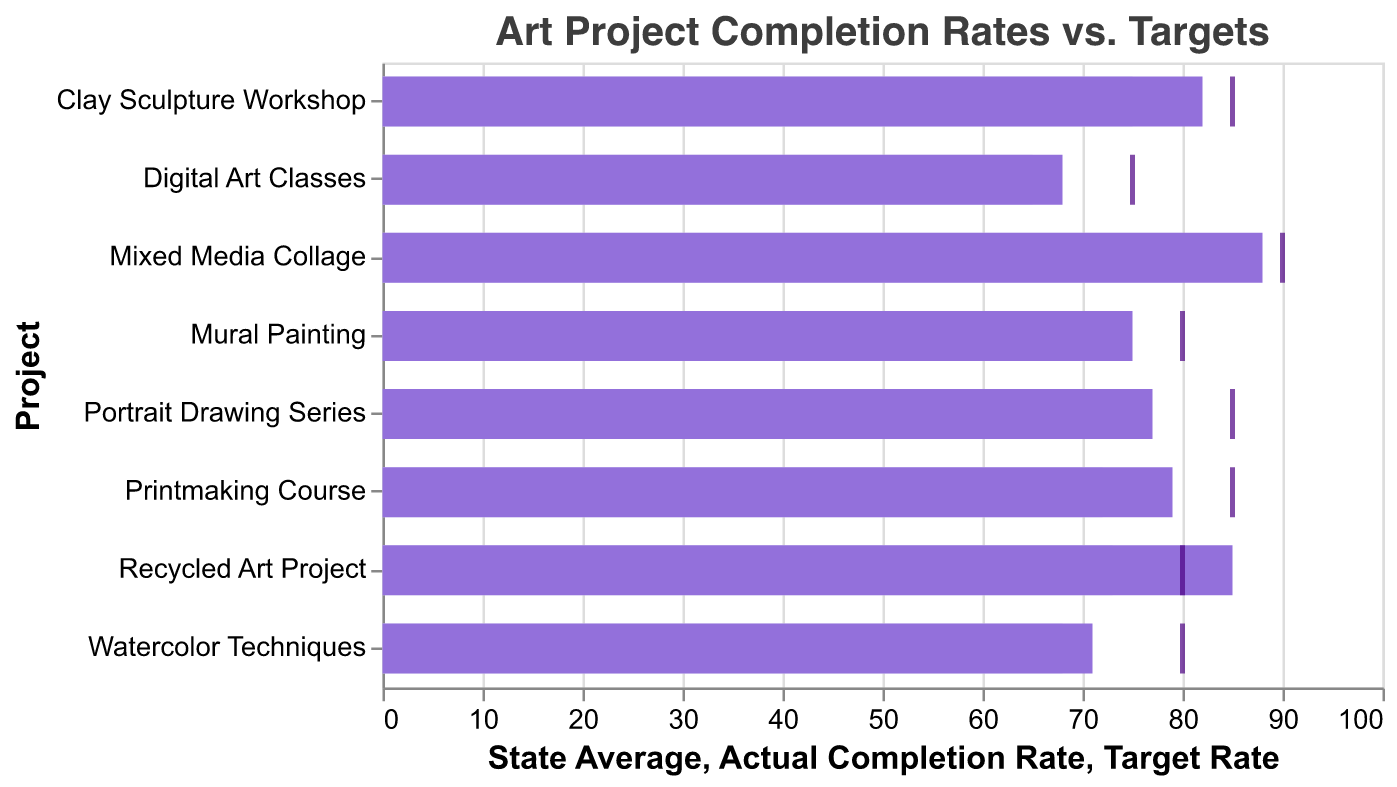What is the title of the figure? The title of the figure is displayed at the top and is usually in larger font size or bold for emphasis.
Answer: Art Project Completion Rates vs. Targets Which art project has the lowest actual completion rate? The lowest actual completion rate is represented by the shortest purple bar.
Answer: Digital Art Classes How many projects have an actual completion rate that meets or exceeds the target rate? Compare the length of the purple bars (actual completion rate) with the positions of the ticks (target rate). Count those that meet or exceed the target.
Answer: 1 (Recycled Art Project) Which project has the highest gap between the actual completion rate and the state average? Compute the difference between the actual completion rate (purple bars) and state average (light bars) for each project, and identify the project with the largest gap.
Answer: Mixed Media Collage What is the difference between the target rate and the actual completion rate for Printmaking Course? Subtract the actual completion rate (purple bar) from the target rate (tick).
Answer: 85 - 79 = 6 Which project falls short the most from its target rate? Compare the tick marks (target rate) with the ends of the purple bars (actual completion rate) and find the largest negative difference.
Answer: Digital Art Classes Are there any projects where the actual completion rate is higher than both the target rate and the state average? Look for projects where the purple bar extends beyond both the tick mark and the light bar.
Answer: No What is the average actual completion rate of all the projects combined? Add up all the actual completion rates and divide by the number of projects. (75 + 82 + 68 + 88 + 79 + 71 + 85 + 77) / 8 = 625 / 8 = 78.125
Answer: 78.125 Which projects have an actual completion rate lower than the state average? Compare the ends of the purple bars (actual completion rate) with the ends of the light bars (state average) to find those that are lower.
Answer: Digital Art Classes, Watercolor Techniques What does the color purple represent in this chart? The purple color represents the actual completion rate of each project.
Answer: Actual Completion Rate 